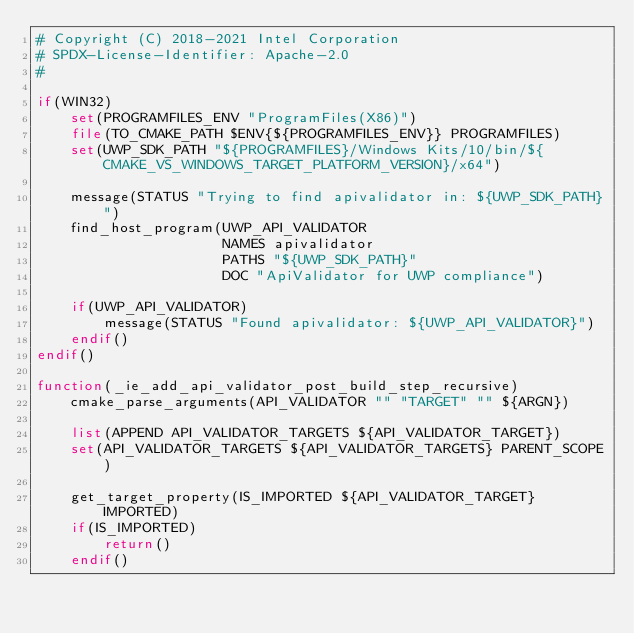Convert code to text. <code><loc_0><loc_0><loc_500><loc_500><_CMake_># Copyright (C) 2018-2021 Intel Corporation
# SPDX-License-Identifier: Apache-2.0
#

if(WIN32)
    set(PROGRAMFILES_ENV "ProgramFiles(X86)")
    file(TO_CMAKE_PATH $ENV{${PROGRAMFILES_ENV}} PROGRAMFILES)
    set(UWP_SDK_PATH "${PROGRAMFILES}/Windows Kits/10/bin/${CMAKE_VS_WINDOWS_TARGET_PLATFORM_VERSION}/x64")

    message(STATUS "Trying to find apivalidator in: ${UWP_SDK_PATH}")
    find_host_program(UWP_API_VALIDATOR
                      NAMES apivalidator
                      PATHS "${UWP_SDK_PATH}"
                      DOC "ApiValidator for UWP compliance")

    if(UWP_API_VALIDATOR)
        message(STATUS "Found apivalidator: ${UWP_API_VALIDATOR}")
    endif()
endif()

function(_ie_add_api_validator_post_build_step_recursive)
    cmake_parse_arguments(API_VALIDATOR "" "TARGET" "" ${ARGN})

    list(APPEND API_VALIDATOR_TARGETS ${API_VALIDATOR_TARGET})
    set(API_VALIDATOR_TARGETS ${API_VALIDATOR_TARGETS} PARENT_SCOPE)

    get_target_property(IS_IMPORTED ${API_VALIDATOR_TARGET} IMPORTED)
    if(IS_IMPORTED)
        return()
    endif()
</code> 